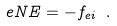Convert formula to latex. <formula><loc_0><loc_0><loc_500><loc_500>e N { E } = - { f } _ { e i } \ .</formula> 